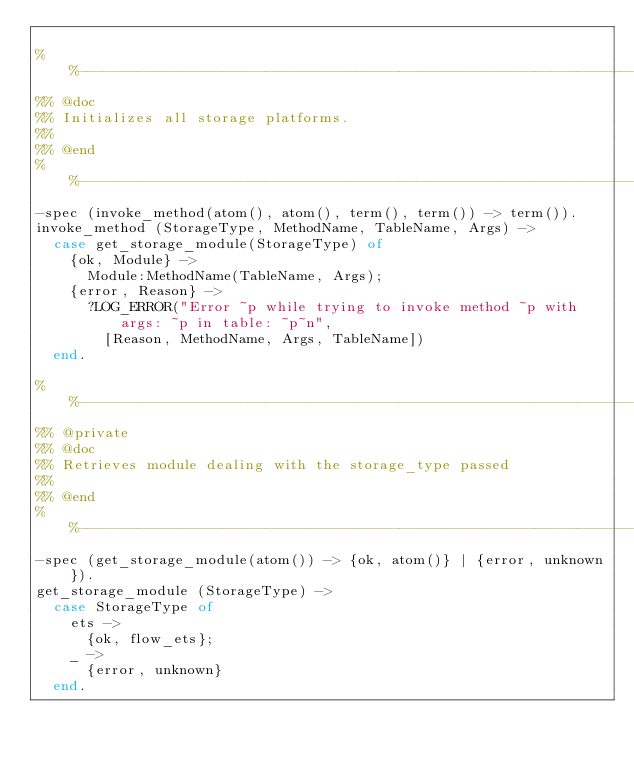Convert code to text. <code><loc_0><loc_0><loc_500><loc_500><_Erlang_>
%%--------------------------------------------------------------------
%% @doc
%% Initializes all storage platforms.
%%
%% @end
%%--------------------------------------------------------------------
-spec (invoke_method(atom(), atom(), term(), term()) -> term()).
invoke_method (StorageType, MethodName, TableName, Args) ->
  case get_storage_module(StorageType) of
    {ok, Module} ->
      Module:MethodName(TableName, Args);
    {error, Reason} ->
      ?LOG_ERROR("Error ~p while trying to invoke method ~p with args: ~p in table: ~p~n",
        [Reason, MethodName, Args, TableName])
  end.

%%--------------------------------------------------------------------
%% @private
%% @doc
%% Retrieves module dealing with the storage_type passed
%%
%% @end
%%--------------------------------------------------------------------
-spec (get_storage_module(atom()) -> {ok, atom()} | {error, unknown}).
get_storage_module (StorageType) ->
  case StorageType of
    ets ->
      {ok, flow_ets};
    _ ->
      {error, unknown}
  end.
</code> 